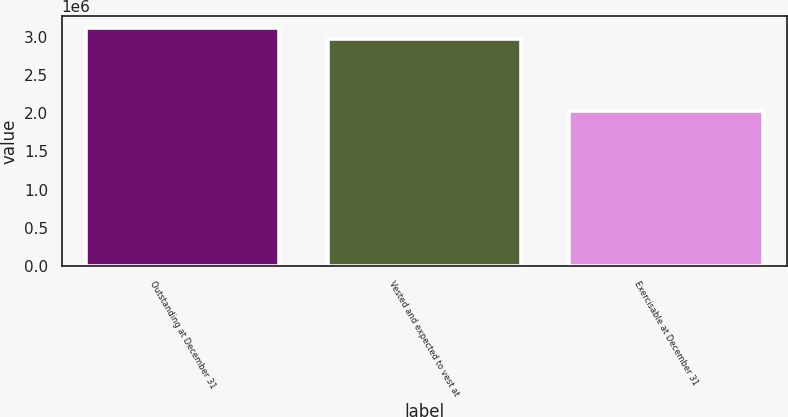Convert chart to OTSL. <chart><loc_0><loc_0><loc_500><loc_500><bar_chart><fcel>Outstanding at December 31<fcel>Vested and expected to vest at<fcel>Exercisable at December 31<nl><fcel>3.11225e+06<fcel>2.97418e+06<fcel>2.02287e+06<nl></chart> 